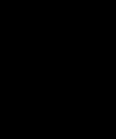<code> <loc_0><loc_0><loc_500><loc_500><_SQL_>

</code> 